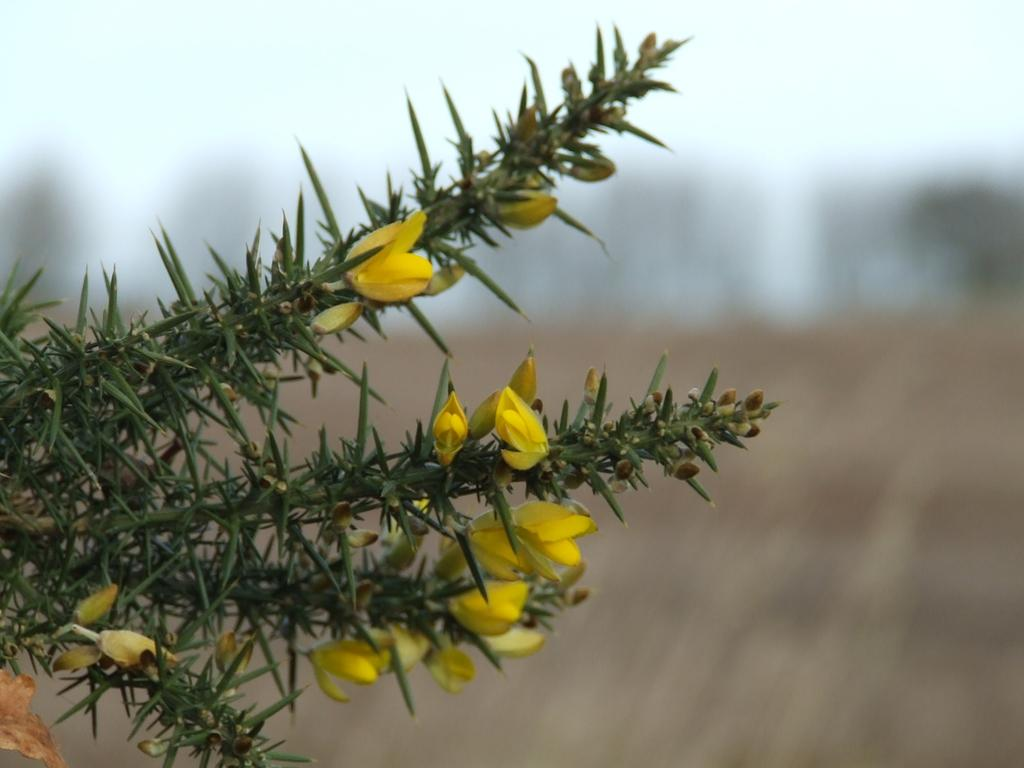What type of plant is on the left side of the image? There is a plant with flowers on the left side of the image. How would you describe the background of the image? The background of the image is blurred. What can be seen in the distance in the image? The sky is visible in the background of the image. Are there any other objects visible in the background? Yes, there are objects visible in the background of the image. Can you see any tomatoes growing in the quicksand in the image? There is no quicksand or tomatoes present in the image. What type of flock is flying over the plant in the image? There is no flock visible in the image. 